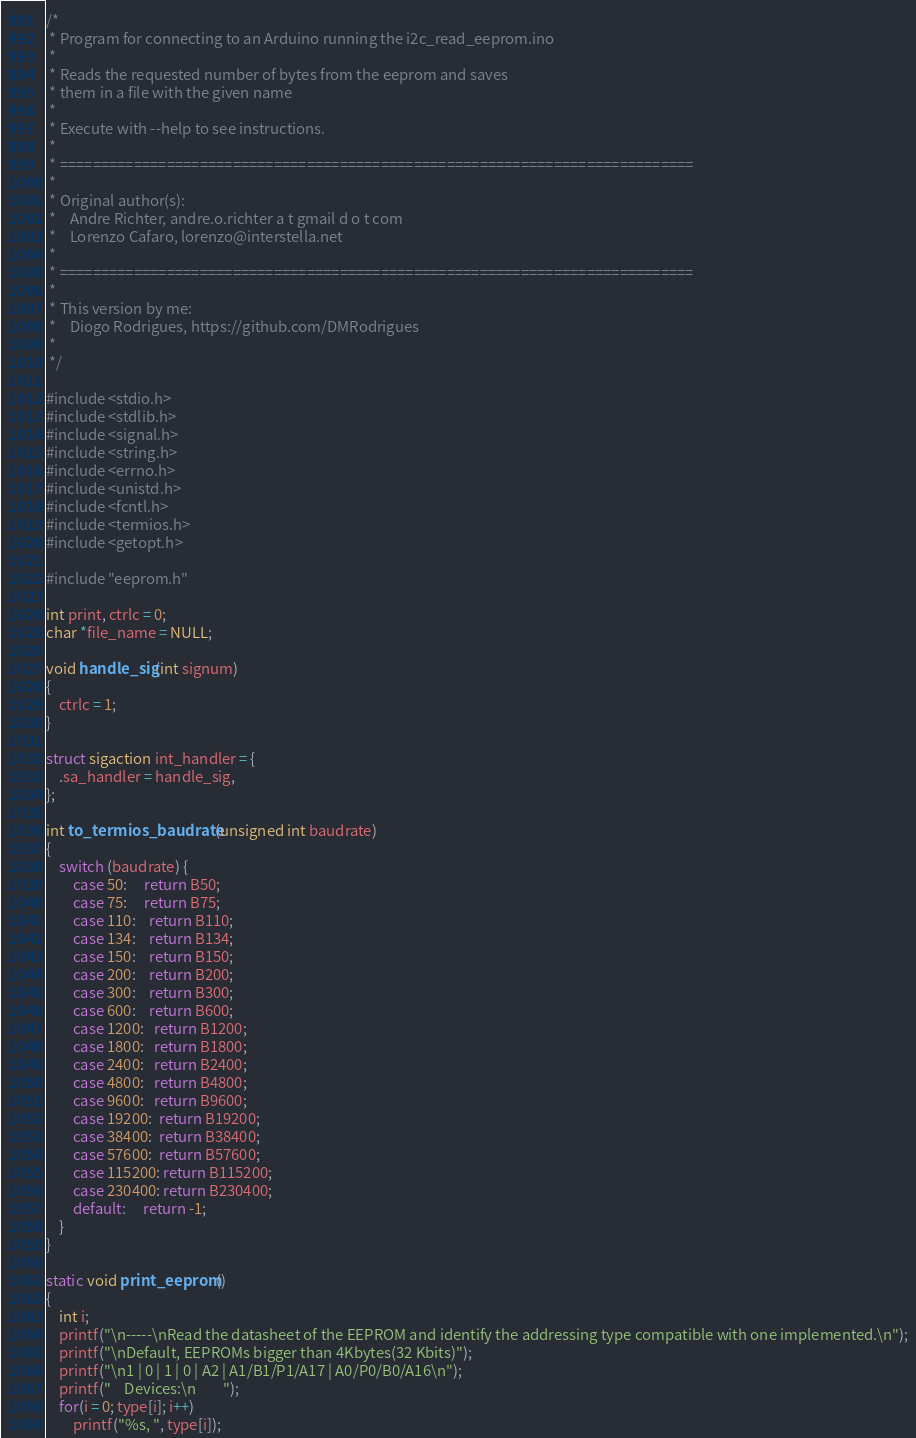<code> <loc_0><loc_0><loc_500><loc_500><_C_>/*
 * Program for connecting to an Arduino running the i2c_read_eeprom.ino
 *
 * Reads the requested number of bytes from the eeprom and saves
 * them in a file with the given name
 *
 * Execute with --help to see instructions.
 *
 * =============================================================================
 *
 * Original author(s):
 *    Andre Richter, andre.o.richter a t gmail d o t com
 *    Lorenzo Cafaro, lorenzo@interstella.net
 *
 * =============================================================================
 *
 * This version by me:
 *    Diogo Rodrigues, https://github.com/DMRodrigues
 *
 */

#include <stdio.h>
#include <stdlib.h>
#include <signal.h>
#include <string.h>
#include <errno.h>
#include <unistd.h>
#include <fcntl.h>
#include <termios.h>
#include <getopt.h>

#include "eeprom.h"

int print, ctrlc = 0;
char *file_name = NULL;

void handle_sig(int signum)
{
	ctrlc = 1;
}

struct sigaction int_handler = {
	.sa_handler = handle_sig,
};

int to_termios_baudrate(unsigned int baudrate)
{
	switch (baudrate) {
		case 50:     return B50;
		case 75:     return B75;
		case 110:    return B110;
		case 134:    return B134;
		case 150:    return B150;
		case 200:    return B200;
		case 300:    return B300;
		case 600:    return B600;
		case 1200:   return B1200;
		case 1800:   return B1800;
		case 2400:   return B2400;
		case 4800:   return B4800;
		case 9600:   return B9600;
		case 19200:  return B19200;
		case 38400:  return B38400;
		case 57600:  return B57600;
		case 115200: return B115200;
		case 230400: return B230400;
		default:     return -1;
	}
}

static void print_eeprom()
{
	int i;
	printf("\n-----\nRead the datasheet of the EEPROM and identify the addressing type compatible with one implemented.\n");
	printf("\nDefault, EEPROMs bigger than 4Kbytes(32 Kbits)");
	printf("\n1 | 0 | 1 | 0 | A2 | A1/B1/P1/A17 | A0/P0/B0/A16\n");
	printf("	Devices:\n		");	
	for(i = 0; type[i]; i++)
		printf("%s, ", type[i]);</code> 